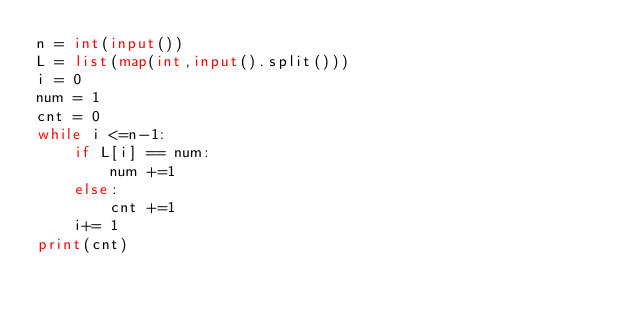<code> <loc_0><loc_0><loc_500><loc_500><_Python_>n = int(input())
L = list(map(int,input().split()))
i = 0
num = 1
cnt = 0
while i <=n-1:
    if L[i] == num:
        num +=1 
    else:
        cnt +=1
    i+= 1
print(cnt)</code> 